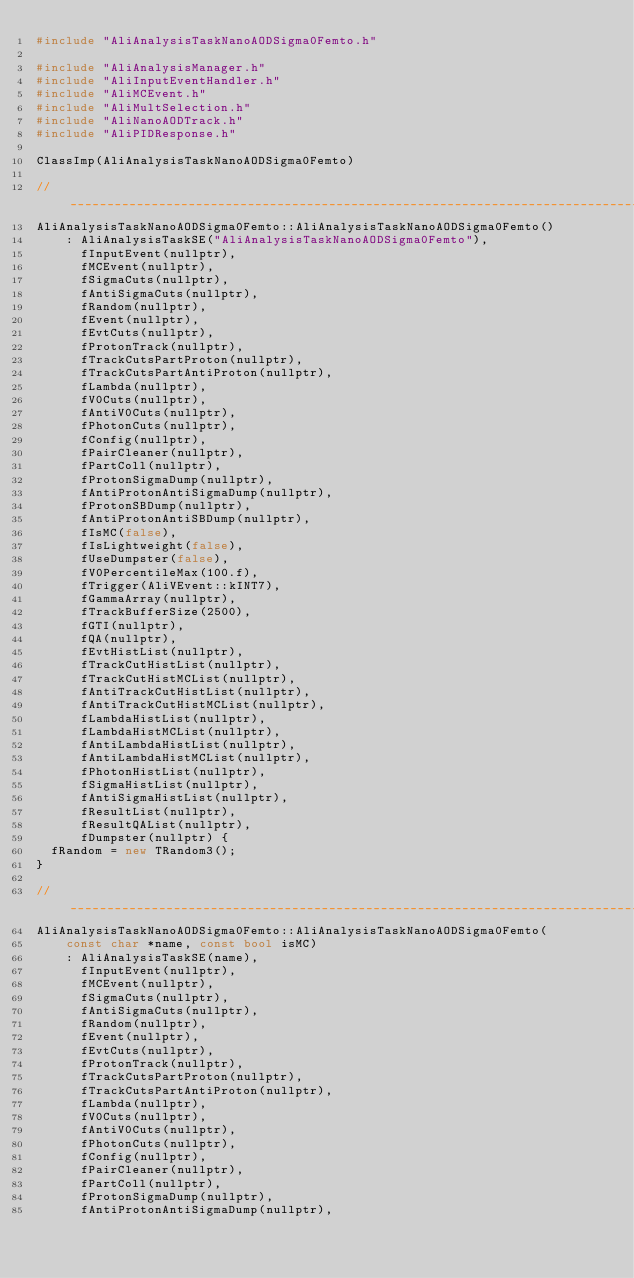<code> <loc_0><loc_0><loc_500><loc_500><_C++_>#include "AliAnalysisTaskNanoAODSigma0Femto.h"

#include "AliAnalysisManager.h"
#include "AliInputEventHandler.h"
#include "AliMCEvent.h"
#include "AliMultSelection.h"
#include "AliNanoAODTrack.h"
#include "AliPIDResponse.h"

ClassImp(AliAnalysisTaskNanoAODSigma0Femto)

//____________________________________________________________________________________________________
AliAnalysisTaskNanoAODSigma0Femto::AliAnalysisTaskNanoAODSigma0Femto()
    : AliAnalysisTaskSE("AliAnalysisTaskNanoAODSigma0Femto"),
      fInputEvent(nullptr),
      fMCEvent(nullptr),
      fSigmaCuts(nullptr),
      fAntiSigmaCuts(nullptr),
      fRandom(nullptr),
      fEvent(nullptr),
      fEvtCuts(nullptr),
      fProtonTrack(nullptr),
      fTrackCutsPartProton(nullptr),
      fTrackCutsPartAntiProton(nullptr),
      fLambda(nullptr),
      fV0Cuts(nullptr),
      fAntiV0Cuts(nullptr),
      fPhotonCuts(nullptr),
      fConfig(nullptr),
      fPairCleaner(nullptr),
      fPartColl(nullptr),
      fProtonSigmaDump(nullptr),
      fAntiProtonAntiSigmaDump(nullptr),
      fProtonSBDump(nullptr),
      fAntiProtonAntiSBDump(nullptr),
      fIsMC(false),
      fIsLightweight(false),
      fUseDumpster(false),
      fV0PercentileMax(100.f),
      fTrigger(AliVEvent::kINT7),
      fGammaArray(nullptr),
      fTrackBufferSize(2500),
      fGTI(nullptr),
      fQA(nullptr),
      fEvtHistList(nullptr),
      fTrackCutHistList(nullptr),
      fTrackCutHistMCList(nullptr),
      fAntiTrackCutHistList(nullptr),
      fAntiTrackCutHistMCList(nullptr),
      fLambdaHistList(nullptr),
      fLambdaHistMCList(nullptr),
      fAntiLambdaHistList(nullptr),
      fAntiLambdaHistMCList(nullptr),
      fPhotonHistList(nullptr),
      fSigmaHistList(nullptr),
      fAntiSigmaHistList(nullptr),
      fResultList(nullptr),
      fResultQAList(nullptr),
      fDumpster(nullptr) {
  fRandom = new TRandom3();
}

//____________________________________________________________________________________________________
AliAnalysisTaskNanoAODSigma0Femto::AliAnalysisTaskNanoAODSigma0Femto(
    const char *name, const bool isMC)
    : AliAnalysisTaskSE(name),
      fInputEvent(nullptr),
      fMCEvent(nullptr),
      fSigmaCuts(nullptr),
      fAntiSigmaCuts(nullptr),
      fRandom(nullptr),
      fEvent(nullptr),
      fEvtCuts(nullptr),
      fProtonTrack(nullptr),
      fTrackCutsPartProton(nullptr),
      fTrackCutsPartAntiProton(nullptr),
      fLambda(nullptr),
      fV0Cuts(nullptr),
      fAntiV0Cuts(nullptr),
      fPhotonCuts(nullptr),
      fConfig(nullptr),
      fPairCleaner(nullptr),
      fPartColl(nullptr),
      fProtonSigmaDump(nullptr),
      fAntiProtonAntiSigmaDump(nullptr),</code> 